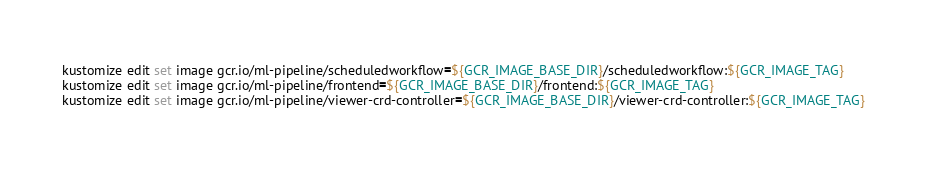<code> <loc_0><loc_0><loc_500><loc_500><_Bash_>kustomize edit set image gcr.io/ml-pipeline/scheduledworkflow=${GCR_IMAGE_BASE_DIR}/scheduledworkflow:${GCR_IMAGE_TAG}
kustomize edit set image gcr.io/ml-pipeline/frontend=${GCR_IMAGE_BASE_DIR}/frontend:${GCR_IMAGE_TAG}
kustomize edit set image gcr.io/ml-pipeline/viewer-crd-controller=${GCR_IMAGE_BASE_DIR}/viewer-crd-controller:${GCR_IMAGE_TAG}</code> 